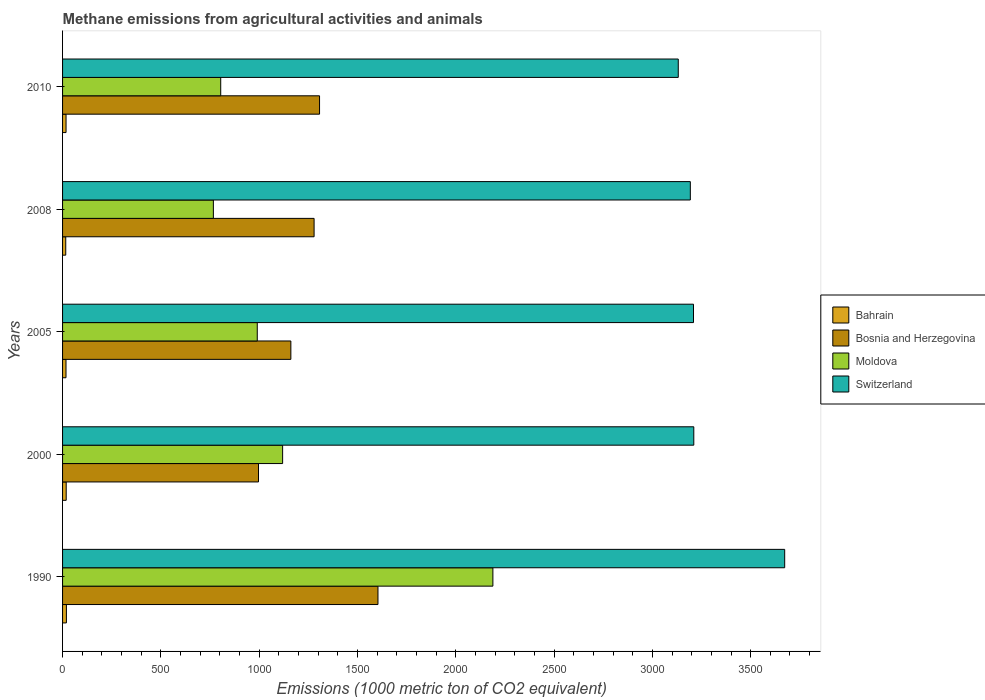How many groups of bars are there?
Provide a succinct answer. 5. Are the number of bars per tick equal to the number of legend labels?
Provide a short and direct response. Yes. Are the number of bars on each tick of the Y-axis equal?
Keep it short and to the point. Yes. What is the label of the 4th group of bars from the top?
Ensure brevity in your answer.  2000. In how many cases, is the number of bars for a given year not equal to the number of legend labels?
Your answer should be compact. 0. What is the amount of methane emitted in Bosnia and Herzegovina in 2010?
Keep it short and to the point. 1307.1. In which year was the amount of methane emitted in Bosnia and Herzegovina maximum?
Your answer should be compact. 1990. In which year was the amount of methane emitted in Bahrain minimum?
Make the answer very short. 2008. What is the total amount of methane emitted in Switzerland in the graph?
Give a very brief answer. 1.64e+04. What is the difference between the amount of methane emitted in Switzerland in 2010 and the amount of methane emitted in Bahrain in 2005?
Keep it short and to the point. 3114.2. What is the average amount of methane emitted in Switzerland per year?
Ensure brevity in your answer.  3283.54. In the year 2005, what is the difference between the amount of methane emitted in Moldova and amount of methane emitted in Switzerland?
Provide a short and direct response. -2218.9. What is the ratio of the amount of methane emitted in Moldova in 1990 to that in 2008?
Your answer should be compact. 2.85. Is the difference between the amount of methane emitted in Moldova in 2000 and 2005 greater than the difference between the amount of methane emitted in Switzerland in 2000 and 2005?
Your response must be concise. Yes. What is the difference between the highest and the second highest amount of methane emitted in Moldova?
Provide a short and direct response. 1069.5. What is the difference between the highest and the lowest amount of methane emitted in Bahrain?
Offer a very short reply. 3.3. In how many years, is the amount of methane emitted in Bosnia and Herzegovina greater than the average amount of methane emitted in Bosnia and Herzegovina taken over all years?
Make the answer very short. 3. Is it the case that in every year, the sum of the amount of methane emitted in Bosnia and Herzegovina and amount of methane emitted in Switzerland is greater than the sum of amount of methane emitted in Bahrain and amount of methane emitted in Moldova?
Your answer should be very brief. No. What does the 2nd bar from the top in 2010 represents?
Provide a succinct answer. Moldova. What does the 1st bar from the bottom in 2000 represents?
Ensure brevity in your answer.  Bahrain. Is it the case that in every year, the sum of the amount of methane emitted in Bahrain and amount of methane emitted in Bosnia and Herzegovina is greater than the amount of methane emitted in Switzerland?
Provide a short and direct response. No. Are all the bars in the graph horizontal?
Offer a terse response. Yes. What is the difference between two consecutive major ticks on the X-axis?
Give a very brief answer. 500. Does the graph contain any zero values?
Keep it short and to the point. No. Does the graph contain grids?
Your answer should be compact. No. Where does the legend appear in the graph?
Offer a terse response. Center right. How many legend labels are there?
Your answer should be very brief. 4. What is the title of the graph?
Your response must be concise. Methane emissions from agricultural activities and animals. Does "Uruguay" appear as one of the legend labels in the graph?
Provide a succinct answer. No. What is the label or title of the X-axis?
Keep it short and to the point. Emissions (1000 metric ton of CO2 equivalent). What is the Emissions (1000 metric ton of CO2 equivalent) of Bosnia and Herzegovina in 1990?
Your response must be concise. 1604.3. What is the Emissions (1000 metric ton of CO2 equivalent) in Moldova in 1990?
Give a very brief answer. 2188.8. What is the Emissions (1000 metric ton of CO2 equivalent) of Switzerland in 1990?
Your response must be concise. 3673. What is the Emissions (1000 metric ton of CO2 equivalent) of Bahrain in 2000?
Make the answer very short. 18.5. What is the Emissions (1000 metric ton of CO2 equivalent) in Bosnia and Herzegovina in 2000?
Your answer should be very brief. 996.6. What is the Emissions (1000 metric ton of CO2 equivalent) of Moldova in 2000?
Your answer should be compact. 1119.3. What is the Emissions (1000 metric ton of CO2 equivalent) of Switzerland in 2000?
Give a very brief answer. 3210.7. What is the Emissions (1000 metric ton of CO2 equivalent) of Bosnia and Herzegovina in 2005?
Provide a short and direct response. 1161.2. What is the Emissions (1000 metric ton of CO2 equivalent) of Moldova in 2005?
Your answer should be compact. 990.3. What is the Emissions (1000 metric ton of CO2 equivalent) in Switzerland in 2005?
Your answer should be compact. 3209.2. What is the Emissions (1000 metric ton of CO2 equivalent) in Bahrain in 2008?
Offer a very short reply. 16.2. What is the Emissions (1000 metric ton of CO2 equivalent) in Bosnia and Herzegovina in 2008?
Your answer should be very brief. 1279.4. What is the Emissions (1000 metric ton of CO2 equivalent) of Moldova in 2008?
Ensure brevity in your answer.  767.1. What is the Emissions (1000 metric ton of CO2 equivalent) in Switzerland in 2008?
Offer a very short reply. 3193.1. What is the Emissions (1000 metric ton of CO2 equivalent) of Bosnia and Herzegovina in 2010?
Give a very brief answer. 1307.1. What is the Emissions (1000 metric ton of CO2 equivalent) in Moldova in 2010?
Provide a short and direct response. 804.4. What is the Emissions (1000 metric ton of CO2 equivalent) of Switzerland in 2010?
Your response must be concise. 3131.7. Across all years, what is the maximum Emissions (1000 metric ton of CO2 equivalent) in Bahrain?
Provide a succinct answer. 19.5. Across all years, what is the maximum Emissions (1000 metric ton of CO2 equivalent) of Bosnia and Herzegovina?
Your response must be concise. 1604.3. Across all years, what is the maximum Emissions (1000 metric ton of CO2 equivalent) in Moldova?
Make the answer very short. 2188.8. Across all years, what is the maximum Emissions (1000 metric ton of CO2 equivalent) of Switzerland?
Your answer should be compact. 3673. Across all years, what is the minimum Emissions (1000 metric ton of CO2 equivalent) of Bosnia and Herzegovina?
Your answer should be very brief. 996.6. Across all years, what is the minimum Emissions (1000 metric ton of CO2 equivalent) of Moldova?
Give a very brief answer. 767.1. Across all years, what is the minimum Emissions (1000 metric ton of CO2 equivalent) of Switzerland?
Offer a terse response. 3131.7. What is the total Emissions (1000 metric ton of CO2 equivalent) of Bahrain in the graph?
Your answer should be compact. 89.4. What is the total Emissions (1000 metric ton of CO2 equivalent) of Bosnia and Herzegovina in the graph?
Your response must be concise. 6348.6. What is the total Emissions (1000 metric ton of CO2 equivalent) of Moldova in the graph?
Your answer should be compact. 5869.9. What is the total Emissions (1000 metric ton of CO2 equivalent) in Switzerland in the graph?
Keep it short and to the point. 1.64e+04. What is the difference between the Emissions (1000 metric ton of CO2 equivalent) of Bosnia and Herzegovina in 1990 and that in 2000?
Your answer should be very brief. 607.7. What is the difference between the Emissions (1000 metric ton of CO2 equivalent) of Moldova in 1990 and that in 2000?
Your answer should be compact. 1069.5. What is the difference between the Emissions (1000 metric ton of CO2 equivalent) of Switzerland in 1990 and that in 2000?
Keep it short and to the point. 462.3. What is the difference between the Emissions (1000 metric ton of CO2 equivalent) of Bosnia and Herzegovina in 1990 and that in 2005?
Your response must be concise. 443.1. What is the difference between the Emissions (1000 metric ton of CO2 equivalent) of Moldova in 1990 and that in 2005?
Your response must be concise. 1198.5. What is the difference between the Emissions (1000 metric ton of CO2 equivalent) in Switzerland in 1990 and that in 2005?
Provide a succinct answer. 463.8. What is the difference between the Emissions (1000 metric ton of CO2 equivalent) in Bahrain in 1990 and that in 2008?
Make the answer very short. 3.3. What is the difference between the Emissions (1000 metric ton of CO2 equivalent) of Bosnia and Herzegovina in 1990 and that in 2008?
Offer a terse response. 324.9. What is the difference between the Emissions (1000 metric ton of CO2 equivalent) of Moldova in 1990 and that in 2008?
Keep it short and to the point. 1421.7. What is the difference between the Emissions (1000 metric ton of CO2 equivalent) in Switzerland in 1990 and that in 2008?
Give a very brief answer. 479.9. What is the difference between the Emissions (1000 metric ton of CO2 equivalent) of Bosnia and Herzegovina in 1990 and that in 2010?
Provide a succinct answer. 297.2. What is the difference between the Emissions (1000 metric ton of CO2 equivalent) in Moldova in 1990 and that in 2010?
Provide a succinct answer. 1384.4. What is the difference between the Emissions (1000 metric ton of CO2 equivalent) in Switzerland in 1990 and that in 2010?
Offer a terse response. 541.3. What is the difference between the Emissions (1000 metric ton of CO2 equivalent) of Bahrain in 2000 and that in 2005?
Your response must be concise. 1. What is the difference between the Emissions (1000 metric ton of CO2 equivalent) in Bosnia and Herzegovina in 2000 and that in 2005?
Offer a terse response. -164.6. What is the difference between the Emissions (1000 metric ton of CO2 equivalent) in Moldova in 2000 and that in 2005?
Give a very brief answer. 129. What is the difference between the Emissions (1000 metric ton of CO2 equivalent) in Bahrain in 2000 and that in 2008?
Ensure brevity in your answer.  2.3. What is the difference between the Emissions (1000 metric ton of CO2 equivalent) in Bosnia and Herzegovina in 2000 and that in 2008?
Provide a short and direct response. -282.8. What is the difference between the Emissions (1000 metric ton of CO2 equivalent) of Moldova in 2000 and that in 2008?
Ensure brevity in your answer.  352.2. What is the difference between the Emissions (1000 metric ton of CO2 equivalent) of Bahrain in 2000 and that in 2010?
Offer a terse response. 0.8. What is the difference between the Emissions (1000 metric ton of CO2 equivalent) in Bosnia and Herzegovina in 2000 and that in 2010?
Offer a terse response. -310.5. What is the difference between the Emissions (1000 metric ton of CO2 equivalent) in Moldova in 2000 and that in 2010?
Provide a succinct answer. 314.9. What is the difference between the Emissions (1000 metric ton of CO2 equivalent) in Switzerland in 2000 and that in 2010?
Provide a succinct answer. 79. What is the difference between the Emissions (1000 metric ton of CO2 equivalent) in Bosnia and Herzegovina in 2005 and that in 2008?
Keep it short and to the point. -118.2. What is the difference between the Emissions (1000 metric ton of CO2 equivalent) of Moldova in 2005 and that in 2008?
Offer a very short reply. 223.2. What is the difference between the Emissions (1000 metric ton of CO2 equivalent) in Bosnia and Herzegovina in 2005 and that in 2010?
Ensure brevity in your answer.  -145.9. What is the difference between the Emissions (1000 metric ton of CO2 equivalent) in Moldova in 2005 and that in 2010?
Offer a very short reply. 185.9. What is the difference between the Emissions (1000 metric ton of CO2 equivalent) in Switzerland in 2005 and that in 2010?
Provide a succinct answer. 77.5. What is the difference between the Emissions (1000 metric ton of CO2 equivalent) in Bahrain in 2008 and that in 2010?
Give a very brief answer. -1.5. What is the difference between the Emissions (1000 metric ton of CO2 equivalent) in Bosnia and Herzegovina in 2008 and that in 2010?
Keep it short and to the point. -27.7. What is the difference between the Emissions (1000 metric ton of CO2 equivalent) in Moldova in 2008 and that in 2010?
Keep it short and to the point. -37.3. What is the difference between the Emissions (1000 metric ton of CO2 equivalent) of Switzerland in 2008 and that in 2010?
Your answer should be compact. 61.4. What is the difference between the Emissions (1000 metric ton of CO2 equivalent) in Bahrain in 1990 and the Emissions (1000 metric ton of CO2 equivalent) in Bosnia and Herzegovina in 2000?
Ensure brevity in your answer.  -977.1. What is the difference between the Emissions (1000 metric ton of CO2 equivalent) of Bahrain in 1990 and the Emissions (1000 metric ton of CO2 equivalent) of Moldova in 2000?
Your response must be concise. -1099.8. What is the difference between the Emissions (1000 metric ton of CO2 equivalent) of Bahrain in 1990 and the Emissions (1000 metric ton of CO2 equivalent) of Switzerland in 2000?
Give a very brief answer. -3191.2. What is the difference between the Emissions (1000 metric ton of CO2 equivalent) of Bosnia and Herzegovina in 1990 and the Emissions (1000 metric ton of CO2 equivalent) of Moldova in 2000?
Your answer should be compact. 485. What is the difference between the Emissions (1000 metric ton of CO2 equivalent) in Bosnia and Herzegovina in 1990 and the Emissions (1000 metric ton of CO2 equivalent) in Switzerland in 2000?
Offer a terse response. -1606.4. What is the difference between the Emissions (1000 metric ton of CO2 equivalent) of Moldova in 1990 and the Emissions (1000 metric ton of CO2 equivalent) of Switzerland in 2000?
Provide a succinct answer. -1021.9. What is the difference between the Emissions (1000 metric ton of CO2 equivalent) in Bahrain in 1990 and the Emissions (1000 metric ton of CO2 equivalent) in Bosnia and Herzegovina in 2005?
Offer a very short reply. -1141.7. What is the difference between the Emissions (1000 metric ton of CO2 equivalent) in Bahrain in 1990 and the Emissions (1000 metric ton of CO2 equivalent) in Moldova in 2005?
Keep it short and to the point. -970.8. What is the difference between the Emissions (1000 metric ton of CO2 equivalent) in Bahrain in 1990 and the Emissions (1000 metric ton of CO2 equivalent) in Switzerland in 2005?
Keep it short and to the point. -3189.7. What is the difference between the Emissions (1000 metric ton of CO2 equivalent) of Bosnia and Herzegovina in 1990 and the Emissions (1000 metric ton of CO2 equivalent) of Moldova in 2005?
Provide a succinct answer. 614. What is the difference between the Emissions (1000 metric ton of CO2 equivalent) in Bosnia and Herzegovina in 1990 and the Emissions (1000 metric ton of CO2 equivalent) in Switzerland in 2005?
Keep it short and to the point. -1604.9. What is the difference between the Emissions (1000 metric ton of CO2 equivalent) of Moldova in 1990 and the Emissions (1000 metric ton of CO2 equivalent) of Switzerland in 2005?
Make the answer very short. -1020.4. What is the difference between the Emissions (1000 metric ton of CO2 equivalent) in Bahrain in 1990 and the Emissions (1000 metric ton of CO2 equivalent) in Bosnia and Herzegovina in 2008?
Your response must be concise. -1259.9. What is the difference between the Emissions (1000 metric ton of CO2 equivalent) in Bahrain in 1990 and the Emissions (1000 metric ton of CO2 equivalent) in Moldova in 2008?
Your answer should be compact. -747.6. What is the difference between the Emissions (1000 metric ton of CO2 equivalent) in Bahrain in 1990 and the Emissions (1000 metric ton of CO2 equivalent) in Switzerland in 2008?
Offer a very short reply. -3173.6. What is the difference between the Emissions (1000 metric ton of CO2 equivalent) in Bosnia and Herzegovina in 1990 and the Emissions (1000 metric ton of CO2 equivalent) in Moldova in 2008?
Ensure brevity in your answer.  837.2. What is the difference between the Emissions (1000 metric ton of CO2 equivalent) of Bosnia and Herzegovina in 1990 and the Emissions (1000 metric ton of CO2 equivalent) of Switzerland in 2008?
Offer a very short reply. -1588.8. What is the difference between the Emissions (1000 metric ton of CO2 equivalent) in Moldova in 1990 and the Emissions (1000 metric ton of CO2 equivalent) in Switzerland in 2008?
Your answer should be very brief. -1004.3. What is the difference between the Emissions (1000 metric ton of CO2 equivalent) in Bahrain in 1990 and the Emissions (1000 metric ton of CO2 equivalent) in Bosnia and Herzegovina in 2010?
Keep it short and to the point. -1287.6. What is the difference between the Emissions (1000 metric ton of CO2 equivalent) in Bahrain in 1990 and the Emissions (1000 metric ton of CO2 equivalent) in Moldova in 2010?
Make the answer very short. -784.9. What is the difference between the Emissions (1000 metric ton of CO2 equivalent) in Bahrain in 1990 and the Emissions (1000 metric ton of CO2 equivalent) in Switzerland in 2010?
Your answer should be compact. -3112.2. What is the difference between the Emissions (1000 metric ton of CO2 equivalent) of Bosnia and Herzegovina in 1990 and the Emissions (1000 metric ton of CO2 equivalent) of Moldova in 2010?
Offer a very short reply. 799.9. What is the difference between the Emissions (1000 metric ton of CO2 equivalent) of Bosnia and Herzegovina in 1990 and the Emissions (1000 metric ton of CO2 equivalent) of Switzerland in 2010?
Keep it short and to the point. -1527.4. What is the difference between the Emissions (1000 metric ton of CO2 equivalent) in Moldova in 1990 and the Emissions (1000 metric ton of CO2 equivalent) in Switzerland in 2010?
Make the answer very short. -942.9. What is the difference between the Emissions (1000 metric ton of CO2 equivalent) in Bahrain in 2000 and the Emissions (1000 metric ton of CO2 equivalent) in Bosnia and Herzegovina in 2005?
Keep it short and to the point. -1142.7. What is the difference between the Emissions (1000 metric ton of CO2 equivalent) in Bahrain in 2000 and the Emissions (1000 metric ton of CO2 equivalent) in Moldova in 2005?
Provide a succinct answer. -971.8. What is the difference between the Emissions (1000 metric ton of CO2 equivalent) in Bahrain in 2000 and the Emissions (1000 metric ton of CO2 equivalent) in Switzerland in 2005?
Your response must be concise. -3190.7. What is the difference between the Emissions (1000 metric ton of CO2 equivalent) of Bosnia and Herzegovina in 2000 and the Emissions (1000 metric ton of CO2 equivalent) of Moldova in 2005?
Provide a succinct answer. 6.3. What is the difference between the Emissions (1000 metric ton of CO2 equivalent) of Bosnia and Herzegovina in 2000 and the Emissions (1000 metric ton of CO2 equivalent) of Switzerland in 2005?
Keep it short and to the point. -2212.6. What is the difference between the Emissions (1000 metric ton of CO2 equivalent) of Moldova in 2000 and the Emissions (1000 metric ton of CO2 equivalent) of Switzerland in 2005?
Make the answer very short. -2089.9. What is the difference between the Emissions (1000 metric ton of CO2 equivalent) of Bahrain in 2000 and the Emissions (1000 metric ton of CO2 equivalent) of Bosnia and Herzegovina in 2008?
Provide a short and direct response. -1260.9. What is the difference between the Emissions (1000 metric ton of CO2 equivalent) in Bahrain in 2000 and the Emissions (1000 metric ton of CO2 equivalent) in Moldova in 2008?
Ensure brevity in your answer.  -748.6. What is the difference between the Emissions (1000 metric ton of CO2 equivalent) of Bahrain in 2000 and the Emissions (1000 metric ton of CO2 equivalent) of Switzerland in 2008?
Your answer should be very brief. -3174.6. What is the difference between the Emissions (1000 metric ton of CO2 equivalent) in Bosnia and Herzegovina in 2000 and the Emissions (1000 metric ton of CO2 equivalent) in Moldova in 2008?
Make the answer very short. 229.5. What is the difference between the Emissions (1000 metric ton of CO2 equivalent) in Bosnia and Herzegovina in 2000 and the Emissions (1000 metric ton of CO2 equivalent) in Switzerland in 2008?
Provide a succinct answer. -2196.5. What is the difference between the Emissions (1000 metric ton of CO2 equivalent) in Moldova in 2000 and the Emissions (1000 metric ton of CO2 equivalent) in Switzerland in 2008?
Your answer should be very brief. -2073.8. What is the difference between the Emissions (1000 metric ton of CO2 equivalent) in Bahrain in 2000 and the Emissions (1000 metric ton of CO2 equivalent) in Bosnia and Herzegovina in 2010?
Keep it short and to the point. -1288.6. What is the difference between the Emissions (1000 metric ton of CO2 equivalent) of Bahrain in 2000 and the Emissions (1000 metric ton of CO2 equivalent) of Moldova in 2010?
Give a very brief answer. -785.9. What is the difference between the Emissions (1000 metric ton of CO2 equivalent) of Bahrain in 2000 and the Emissions (1000 metric ton of CO2 equivalent) of Switzerland in 2010?
Your response must be concise. -3113.2. What is the difference between the Emissions (1000 metric ton of CO2 equivalent) of Bosnia and Herzegovina in 2000 and the Emissions (1000 metric ton of CO2 equivalent) of Moldova in 2010?
Keep it short and to the point. 192.2. What is the difference between the Emissions (1000 metric ton of CO2 equivalent) of Bosnia and Herzegovina in 2000 and the Emissions (1000 metric ton of CO2 equivalent) of Switzerland in 2010?
Keep it short and to the point. -2135.1. What is the difference between the Emissions (1000 metric ton of CO2 equivalent) in Moldova in 2000 and the Emissions (1000 metric ton of CO2 equivalent) in Switzerland in 2010?
Offer a very short reply. -2012.4. What is the difference between the Emissions (1000 metric ton of CO2 equivalent) in Bahrain in 2005 and the Emissions (1000 metric ton of CO2 equivalent) in Bosnia and Herzegovina in 2008?
Provide a short and direct response. -1261.9. What is the difference between the Emissions (1000 metric ton of CO2 equivalent) of Bahrain in 2005 and the Emissions (1000 metric ton of CO2 equivalent) of Moldova in 2008?
Provide a short and direct response. -749.6. What is the difference between the Emissions (1000 metric ton of CO2 equivalent) of Bahrain in 2005 and the Emissions (1000 metric ton of CO2 equivalent) of Switzerland in 2008?
Give a very brief answer. -3175.6. What is the difference between the Emissions (1000 metric ton of CO2 equivalent) of Bosnia and Herzegovina in 2005 and the Emissions (1000 metric ton of CO2 equivalent) of Moldova in 2008?
Provide a short and direct response. 394.1. What is the difference between the Emissions (1000 metric ton of CO2 equivalent) in Bosnia and Herzegovina in 2005 and the Emissions (1000 metric ton of CO2 equivalent) in Switzerland in 2008?
Give a very brief answer. -2031.9. What is the difference between the Emissions (1000 metric ton of CO2 equivalent) of Moldova in 2005 and the Emissions (1000 metric ton of CO2 equivalent) of Switzerland in 2008?
Your response must be concise. -2202.8. What is the difference between the Emissions (1000 metric ton of CO2 equivalent) in Bahrain in 2005 and the Emissions (1000 metric ton of CO2 equivalent) in Bosnia and Herzegovina in 2010?
Keep it short and to the point. -1289.6. What is the difference between the Emissions (1000 metric ton of CO2 equivalent) of Bahrain in 2005 and the Emissions (1000 metric ton of CO2 equivalent) of Moldova in 2010?
Make the answer very short. -786.9. What is the difference between the Emissions (1000 metric ton of CO2 equivalent) of Bahrain in 2005 and the Emissions (1000 metric ton of CO2 equivalent) of Switzerland in 2010?
Offer a very short reply. -3114.2. What is the difference between the Emissions (1000 metric ton of CO2 equivalent) of Bosnia and Herzegovina in 2005 and the Emissions (1000 metric ton of CO2 equivalent) of Moldova in 2010?
Your answer should be compact. 356.8. What is the difference between the Emissions (1000 metric ton of CO2 equivalent) in Bosnia and Herzegovina in 2005 and the Emissions (1000 metric ton of CO2 equivalent) in Switzerland in 2010?
Offer a very short reply. -1970.5. What is the difference between the Emissions (1000 metric ton of CO2 equivalent) in Moldova in 2005 and the Emissions (1000 metric ton of CO2 equivalent) in Switzerland in 2010?
Make the answer very short. -2141.4. What is the difference between the Emissions (1000 metric ton of CO2 equivalent) in Bahrain in 2008 and the Emissions (1000 metric ton of CO2 equivalent) in Bosnia and Herzegovina in 2010?
Give a very brief answer. -1290.9. What is the difference between the Emissions (1000 metric ton of CO2 equivalent) of Bahrain in 2008 and the Emissions (1000 metric ton of CO2 equivalent) of Moldova in 2010?
Make the answer very short. -788.2. What is the difference between the Emissions (1000 metric ton of CO2 equivalent) in Bahrain in 2008 and the Emissions (1000 metric ton of CO2 equivalent) in Switzerland in 2010?
Offer a very short reply. -3115.5. What is the difference between the Emissions (1000 metric ton of CO2 equivalent) in Bosnia and Herzegovina in 2008 and the Emissions (1000 metric ton of CO2 equivalent) in Moldova in 2010?
Provide a short and direct response. 475. What is the difference between the Emissions (1000 metric ton of CO2 equivalent) in Bosnia and Herzegovina in 2008 and the Emissions (1000 metric ton of CO2 equivalent) in Switzerland in 2010?
Keep it short and to the point. -1852.3. What is the difference between the Emissions (1000 metric ton of CO2 equivalent) of Moldova in 2008 and the Emissions (1000 metric ton of CO2 equivalent) of Switzerland in 2010?
Provide a succinct answer. -2364.6. What is the average Emissions (1000 metric ton of CO2 equivalent) in Bahrain per year?
Ensure brevity in your answer.  17.88. What is the average Emissions (1000 metric ton of CO2 equivalent) of Bosnia and Herzegovina per year?
Make the answer very short. 1269.72. What is the average Emissions (1000 metric ton of CO2 equivalent) of Moldova per year?
Offer a very short reply. 1173.98. What is the average Emissions (1000 metric ton of CO2 equivalent) in Switzerland per year?
Your answer should be compact. 3283.54. In the year 1990, what is the difference between the Emissions (1000 metric ton of CO2 equivalent) of Bahrain and Emissions (1000 metric ton of CO2 equivalent) of Bosnia and Herzegovina?
Give a very brief answer. -1584.8. In the year 1990, what is the difference between the Emissions (1000 metric ton of CO2 equivalent) of Bahrain and Emissions (1000 metric ton of CO2 equivalent) of Moldova?
Keep it short and to the point. -2169.3. In the year 1990, what is the difference between the Emissions (1000 metric ton of CO2 equivalent) in Bahrain and Emissions (1000 metric ton of CO2 equivalent) in Switzerland?
Give a very brief answer. -3653.5. In the year 1990, what is the difference between the Emissions (1000 metric ton of CO2 equivalent) in Bosnia and Herzegovina and Emissions (1000 metric ton of CO2 equivalent) in Moldova?
Your answer should be very brief. -584.5. In the year 1990, what is the difference between the Emissions (1000 metric ton of CO2 equivalent) in Bosnia and Herzegovina and Emissions (1000 metric ton of CO2 equivalent) in Switzerland?
Make the answer very short. -2068.7. In the year 1990, what is the difference between the Emissions (1000 metric ton of CO2 equivalent) of Moldova and Emissions (1000 metric ton of CO2 equivalent) of Switzerland?
Your answer should be very brief. -1484.2. In the year 2000, what is the difference between the Emissions (1000 metric ton of CO2 equivalent) of Bahrain and Emissions (1000 metric ton of CO2 equivalent) of Bosnia and Herzegovina?
Make the answer very short. -978.1. In the year 2000, what is the difference between the Emissions (1000 metric ton of CO2 equivalent) of Bahrain and Emissions (1000 metric ton of CO2 equivalent) of Moldova?
Keep it short and to the point. -1100.8. In the year 2000, what is the difference between the Emissions (1000 metric ton of CO2 equivalent) in Bahrain and Emissions (1000 metric ton of CO2 equivalent) in Switzerland?
Your response must be concise. -3192.2. In the year 2000, what is the difference between the Emissions (1000 metric ton of CO2 equivalent) in Bosnia and Herzegovina and Emissions (1000 metric ton of CO2 equivalent) in Moldova?
Give a very brief answer. -122.7. In the year 2000, what is the difference between the Emissions (1000 metric ton of CO2 equivalent) in Bosnia and Herzegovina and Emissions (1000 metric ton of CO2 equivalent) in Switzerland?
Your answer should be compact. -2214.1. In the year 2000, what is the difference between the Emissions (1000 metric ton of CO2 equivalent) in Moldova and Emissions (1000 metric ton of CO2 equivalent) in Switzerland?
Offer a terse response. -2091.4. In the year 2005, what is the difference between the Emissions (1000 metric ton of CO2 equivalent) of Bahrain and Emissions (1000 metric ton of CO2 equivalent) of Bosnia and Herzegovina?
Your answer should be compact. -1143.7. In the year 2005, what is the difference between the Emissions (1000 metric ton of CO2 equivalent) of Bahrain and Emissions (1000 metric ton of CO2 equivalent) of Moldova?
Provide a short and direct response. -972.8. In the year 2005, what is the difference between the Emissions (1000 metric ton of CO2 equivalent) of Bahrain and Emissions (1000 metric ton of CO2 equivalent) of Switzerland?
Make the answer very short. -3191.7. In the year 2005, what is the difference between the Emissions (1000 metric ton of CO2 equivalent) in Bosnia and Herzegovina and Emissions (1000 metric ton of CO2 equivalent) in Moldova?
Offer a very short reply. 170.9. In the year 2005, what is the difference between the Emissions (1000 metric ton of CO2 equivalent) of Bosnia and Herzegovina and Emissions (1000 metric ton of CO2 equivalent) of Switzerland?
Offer a very short reply. -2048. In the year 2005, what is the difference between the Emissions (1000 metric ton of CO2 equivalent) of Moldova and Emissions (1000 metric ton of CO2 equivalent) of Switzerland?
Offer a very short reply. -2218.9. In the year 2008, what is the difference between the Emissions (1000 metric ton of CO2 equivalent) in Bahrain and Emissions (1000 metric ton of CO2 equivalent) in Bosnia and Herzegovina?
Keep it short and to the point. -1263.2. In the year 2008, what is the difference between the Emissions (1000 metric ton of CO2 equivalent) in Bahrain and Emissions (1000 metric ton of CO2 equivalent) in Moldova?
Offer a terse response. -750.9. In the year 2008, what is the difference between the Emissions (1000 metric ton of CO2 equivalent) of Bahrain and Emissions (1000 metric ton of CO2 equivalent) of Switzerland?
Ensure brevity in your answer.  -3176.9. In the year 2008, what is the difference between the Emissions (1000 metric ton of CO2 equivalent) in Bosnia and Herzegovina and Emissions (1000 metric ton of CO2 equivalent) in Moldova?
Ensure brevity in your answer.  512.3. In the year 2008, what is the difference between the Emissions (1000 metric ton of CO2 equivalent) of Bosnia and Herzegovina and Emissions (1000 metric ton of CO2 equivalent) of Switzerland?
Offer a terse response. -1913.7. In the year 2008, what is the difference between the Emissions (1000 metric ton of CO2 equivalent) of Moldova and Emissions (1000 metric ton of CO2 equivalent) of Switzerland?
Offer a very short reply. -2426. In the year 2010, what is the difference between the Emissions (1000 metric ton of CO2 equivalent) of Bahrain and Emissions (1000 metric ton of CO2 equivalent) of Bosnia and Herzegovina?
Provide a short and direct response. -1289.4. In the year 2010, what is the difference between the Emissions (1000 metric ton of CO2 equivalent) of Bahrain and Emissions (1000 metric ton of CO2 equivalent) of Moldova?
Provide a short and direct response. -786.7. In the year 2010, what is the difference between the Emissions (1000 metric ton of CO2 equivalent) in Bahrain and Emissions (1000 metric ton of CO2 equivalent) in Switzerland?
Give a very brief answer. -3114. In the year 2010, what is the difference between the Emissions (1000 metric ton of CO2 equivalent) in Bosnia and Herzegovina and Emissions (1000 metric ton of CO2 equivalent) in Moldova?
Give a very brief answer. 502.7. In the year 2010, what is the difference between the Emissions (1000 metric ton of CO2 equivalent) in Bosnia and Herzegovina and Emissions (1000 metric ton of CO2 equivalent) in Switzerland?
Your answer should be very brief. -1824.6. In the year 2010, what is the difference between the Emissions (1000 metric ton of CO2 equivalent) of Moldova and Emissions (1000 metric ton of CO2 equivalent) of Switzerland?
Give a very brief answer. -2327.3. What is the ratio of the Emissions (1000 metric ton of CO2 equivalent) of Bahrain in 1990 to that in 2000?
Make the answer very short. 1.05. What is the ratio of the Emissions (1000 metric ton of CO2 equivalent) in Bosnia and Herzegovina in 1990 to that in 2000?
Offer a very short reply. 1.61. What is the ratio of the Emissions (1000 metric ton of CO2 equivalent) of Moldova in 1990 to that in 2000?
Your answer should be compact. 1.96. What is the ratio of the Emissions (1000 metric ton of CO2 equivalent) of Switzerland in 1990 to that in 2000?
Ensure brevity in your answer.  1.14. What is the ratio of the Emissions (1000 metric ton of CO2 equivalent) of Bahrain in 1990 to that in 2005?
Your answer should be very brief. 1.11. What is the ratio of the Emissions (1000 metric ton of CO2 equivalent) of Bosnia and Herzegovina in 1990 to that in 2005?
Provide a succinct answer. 1.38. What is the ratio of the Emissions (1000 metric ton of CO2 equivalent) in Moldova in 1990 to that in 2005?
Offer a terse response. 2.21. What is the ratio of the Emissions (1000 metric ton of CO2 equivalent) in Switzerland in 1990 to that in 2005?
Offer a terse response. 1.14. What is the ratio of the Emissions (1000 metric ton of CO2 equivalent) in Bahrain in 1990 to that in 2008?
Give a very brief answer. 1.2. What is the ratio of the Emissions (1000 metric ton of CO2 equivalent) of Bosnia and Herzegovina in 1990 to that in 2008?
Your response must be concise. 1.25. What is the ratio of the Emissions (1000 metric ton of CO2 equivalent) of Moldova in 1990 to that in 2008?
Your answer should be very brief. 2.85. What is the ratio of the Emissions (1000 metric ton of CO2 equivalent) of Switzerland in 1990 to that in 2008?
Offer a very short reply. 1.15. What is the ratio of the Emissions (1000 metric ton of CO2 equivalent) of Bahrain in 1990 to that in 2010?
Keep it short and to the point. 1.1. What is the ratio of the Emissions (1000 metric ton of CO2 equivalent) in Bosnia and Herzegovina in 1990 to that in 2010?
Offer a terse response. 1.23. What is the ratio of the Emissions (1000 metric ton of CO2 equivalent) of Moldova in 1990 to that in 2010?
Offer a very short reply. 2.72. What is the ratio of the Emissions (1000 metric ton of CO2 equivalent) of Switzerland in 1990 to that in 2010?
Offer a terse response. 1.17. What is the ratio of the Emissions (1000 metric ton of CO2 equivalent) of Bahrain in 2000 to that in 2005?
Offer a terse response. 1.06. What is the ratio of the Emissions (1000 metric ton of CO2 equivalent) in Bosnia and Herzegovina in 2000 to that in 2005?
Your response must be concise. 0.86. What is the ratio of the Emissions (1000 metric ton of CO2 equivalent) of Moldova in 2000 to that in 2005?
Provide a short and direct response. 1.13. What is the ratio of the Emissions (1000 metric ton of CO2 equivalent) of Bahrain in 2000 to that in 2008?
Give a very brief answer. 1.14. What is the ratio of the Emissions (1000 metric ton of CO2 equivalent) of Bosnia and Herzegovina in 2000 to that in 2008?
Your response must be concise. 0.78. What is the ratio of the Emissions (1000 metric ton of CO2 equivalent) of Moldova in 2000 to that in 2008?
Offer a terse response. 1.46. What is the ratio of the Emissions (1000 metric ton of CO2 equivalent) in Switzerland in 2000 to that in 2008?
Offer a very short reply. 1.01. What is the ratio of the Emissions (1000 metric ton of CO2 equivalent) of Bahrain in 2000 to that in 2010?
Make the answer very short. 1.05. What is the ratio of the Emissions (1000 metric ton of CO2 equivalent) of Bosnia and Herzegovina in 2000 to that in 2010?
Provide a short and direct response. 0.76. What is the ratio of the Emissions (1000 metric ton of CO2 equivalent) in Moldova in 2000 to that in 2010?
Your answer should be compact. 1.39. What is the ratio of the Emissions (1000 metric ton of CO2 equivalent) in Switzerland in 2000 to that in 2010?
Offer a very short reply. 1.03. What is the ratio of the Emissions (1000 metric ton of CO2 equivalent) in Bahrain in 2005 to that in 2008?
Give a very brief answer. 1.08. What is the ratio of the Emissions (1000 metric ton of CO2 equivalent) of Bosnia and Herzegovina in 2005 to that in 2008?
Give a very brief answer. 0.91. What is the ratio of the Emissions (1000 metric ton of CO2 equivalent) in Moldova in 2005 to that in 2008?
Give a very brief answer. 1.29. What is the ratio of the Emissions (1000 metric ton of CO2 equivalent) in Switzerland in 2005 to that in 2008?
Make the answer very short. 1. What is the ratio of the Emissions (1000 metric ton of CO2 equivalent) in Bahrain in 2005 to that in 2010?
Provide a short and direct response. 0.99. What is the ratio of the Emissions (1000 metric ton of CO2 equivalent) of Bosnia and Herzegovina in 2005 to that in 2010?
Your answer should be very brief. 0.89. What is the ratio of the Emissions (1000 metric ton of CO2 equivalent) of Moldova in 2005 to that in 2010?
Keep it short and to the point. 1.23. What is the ratio of the Emissions (1000 metric ton of CO2 equivalent) of Switzerland in 2005 to that in 2010?
Offer a terse response. 1.02. What is the ratio of the Emissions (1000 metric ton of CO2 equivalent) of Bahrain in 2008 to that in 2010?
Give a very brief answer. 0.92. What is the ratio of the Emissions (1000 metric ton of CO2 equivalent) in Bosnia and Herzegovina in 2008 to that in 2010?
Give a very brief answer. 0.98. What is the ratio of the Emissions (1000 metric ton of CO2 equivalent) of Moldova in 2008 to that in 2010?
Your answer should be compact. 0.95. What is the ratio of the Emissions (1000 metric ton of CO2 equivalent) of Switzerland in 2008 to that in 2010?
Provide a succinct answer. 1.02. What is the difference between the highest and the second highest Emissions (1000 metric ton of CO2 equivalent) in Bosnia and Herzegovina?
Make the answer very short. 297.2. What is the difference between the highest and the second highest Emissions (1000 metric ton of CO2 equivalent) in Moldova?
Make the answer very short. 1069.5. What is the difference between the highest and the second highest Emissions (1000 metric ton of CO2 equivalent) in Switzerland?
Offer a very short reply. 462.3. What is the difference between the highest and the lowest Emissions (1000 metric ton of CO2 equivalent) of Bahrain?
Offer a very short reply. 3.3. What is the difference between the highest and the lowest Emissions (1000 metric ton of CO2 equivalent) of Bosnia and Herzegovina?
Ensure brevity in your answer.  607.7. What is the difference between the highest and the lowest Emissions (1000 metric ton of CO2 equivalent) of Moldova?
Keep it short and to the point. 1421.7. What is the difference between the highest and the lowest Emissions (1000 metric ton of CO2 equivalent) in Switzerland?
Keep it short and to the point. 541.3. 